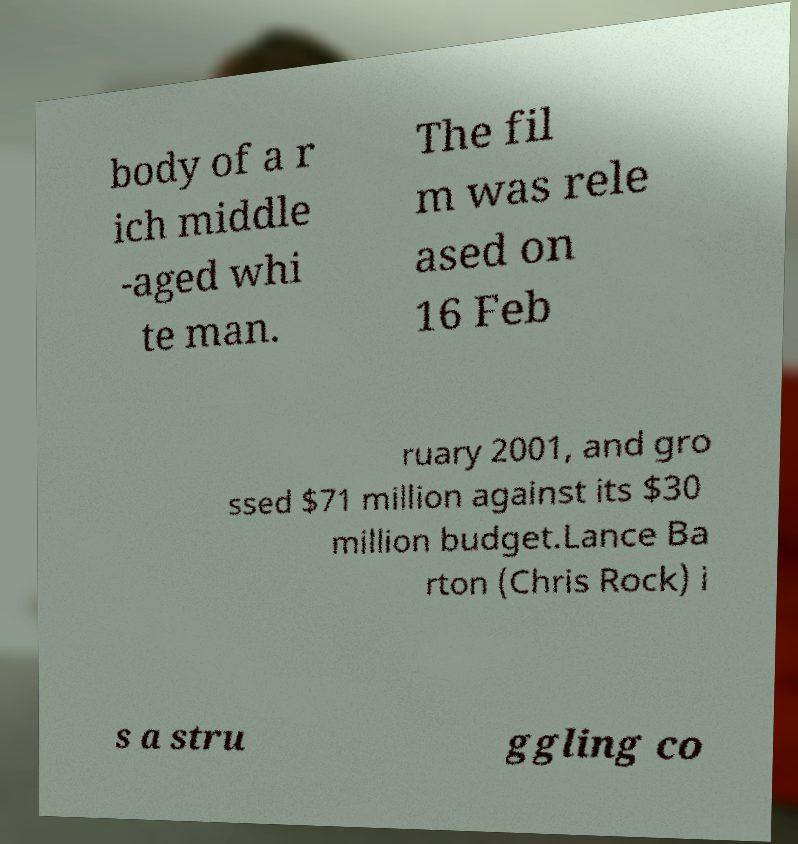For documentation purposes, I need the text within this image transcribed. Could you provide that? body of a r ich middle -aged whi te man. The fil m was rele ased on 16 Feb ruary 2001, and gro ssed $71 million against its $30 million budget.Lance Ba rton (Chris Rock) i s a stru ggling co 